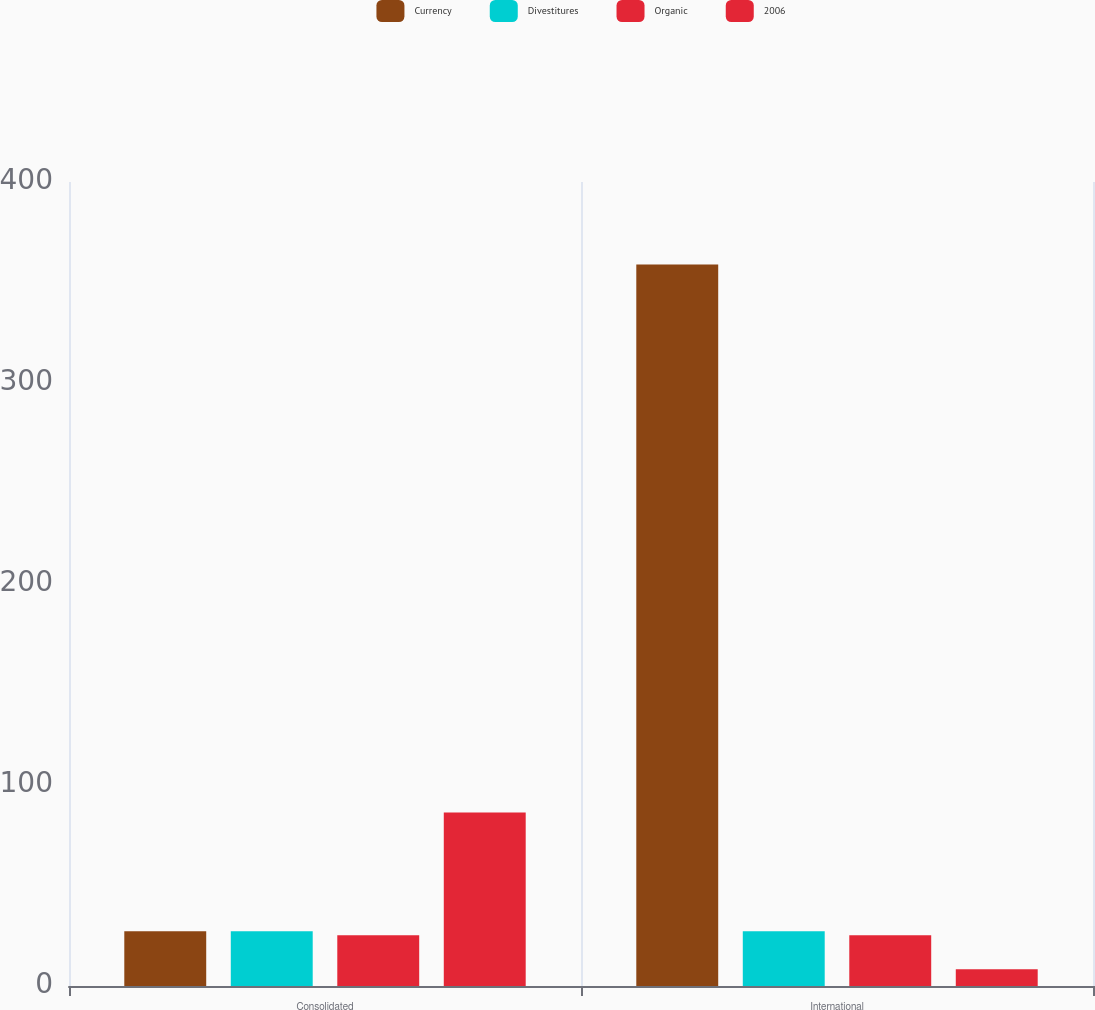Convert chart to OTSL. <chart><loc_0><loc_0><loc_500><loc_500><stacked_bar_chart><ecel><fcel>Consolidated<fcel>International<nl><fcel>Currency<fcel>27.2<fcel>359<nl><fcel>Divestitures<fcel>27.2<fcel>27.2<nl><fcel>Organic<fcel>25.2<fcel>25.2<nl><fcel>2006<fcel>86.3<fcel>8.3<nl></chart> 